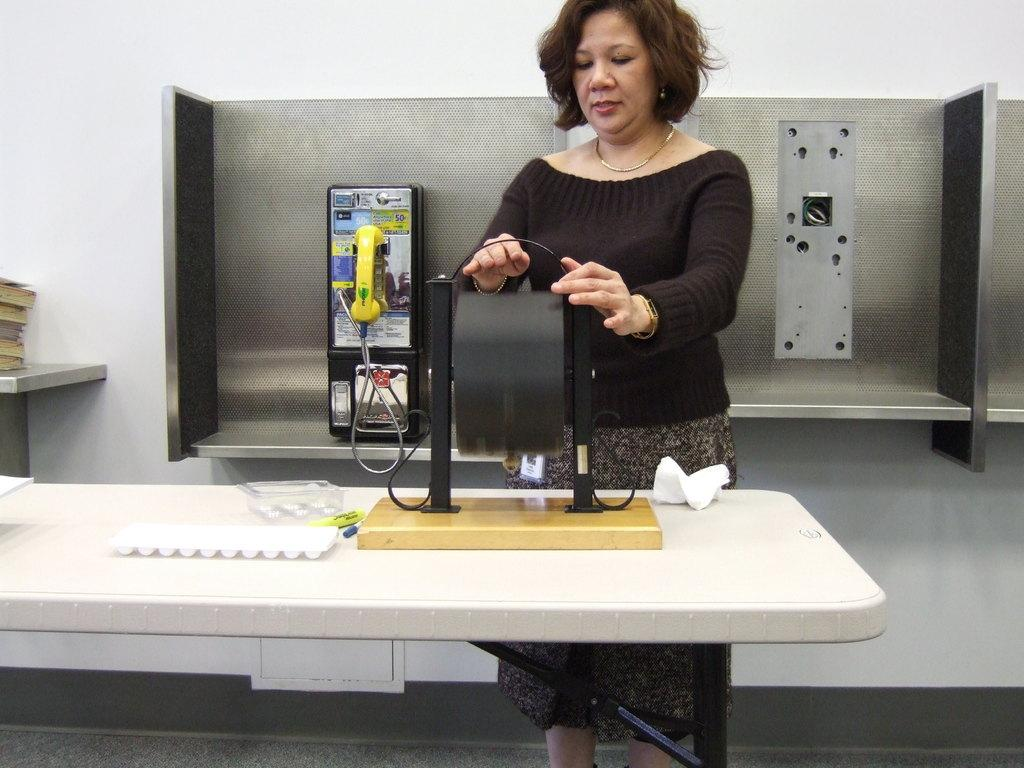Who is present in the image? There is a woman in the image. What is the woman wearing? The woman is wearing a black t-shirt. What is the woman doing in the image? The woman is standing and holding something. What can be seen in the background of the image? There is a telephone and books in the background of the image. What type of oatmeal is being prepared in the cave in the image? There is no cave or oatmeal present in the image. Can you describe the woman's ability to turn into a bird in the image? There is no mention of the woman turning into a bird or any other creature in the image. 